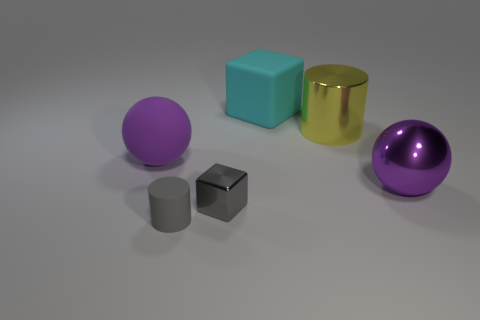What is the color of the rubber thing behind the big shiny cylinder?
Your answer should be compact. Cyan. What is the shape of the gray object that is made of the same material as the big cyan object?
Make the answer very short. Cylinder. Is there anything else that has the same color as the big rubber block?
Your answer should be very brief. No. Is the number of big purple balls that are behind the shiny ball greater than the number of gray metallic blocks left of the tiny gray cylinder?
Your answer should be very brief. Yes. How many purple shiny spheres are the same size as the yellow metal thing?
Provide a short and direct response. 1. Is the number of small gray shiny things that are behind the yellow metal cylinder less than the number of large purple rubber objects in front of the matte cylinder?
Your answer should be very brief. No. Are there any large things of the same shape as the tiny gray matte object?
Ensure brevity in your answer.  Yes. Is the shape of the cyan thing the same as the tiny gray metallic thing?
Your answer should be compact. Yes. How many big things are yellow cylinders or cubes?
Offer a terse response. 2. Is the number of big purple objects greater than the number of large objects?
Your answer should be very brief. No. 